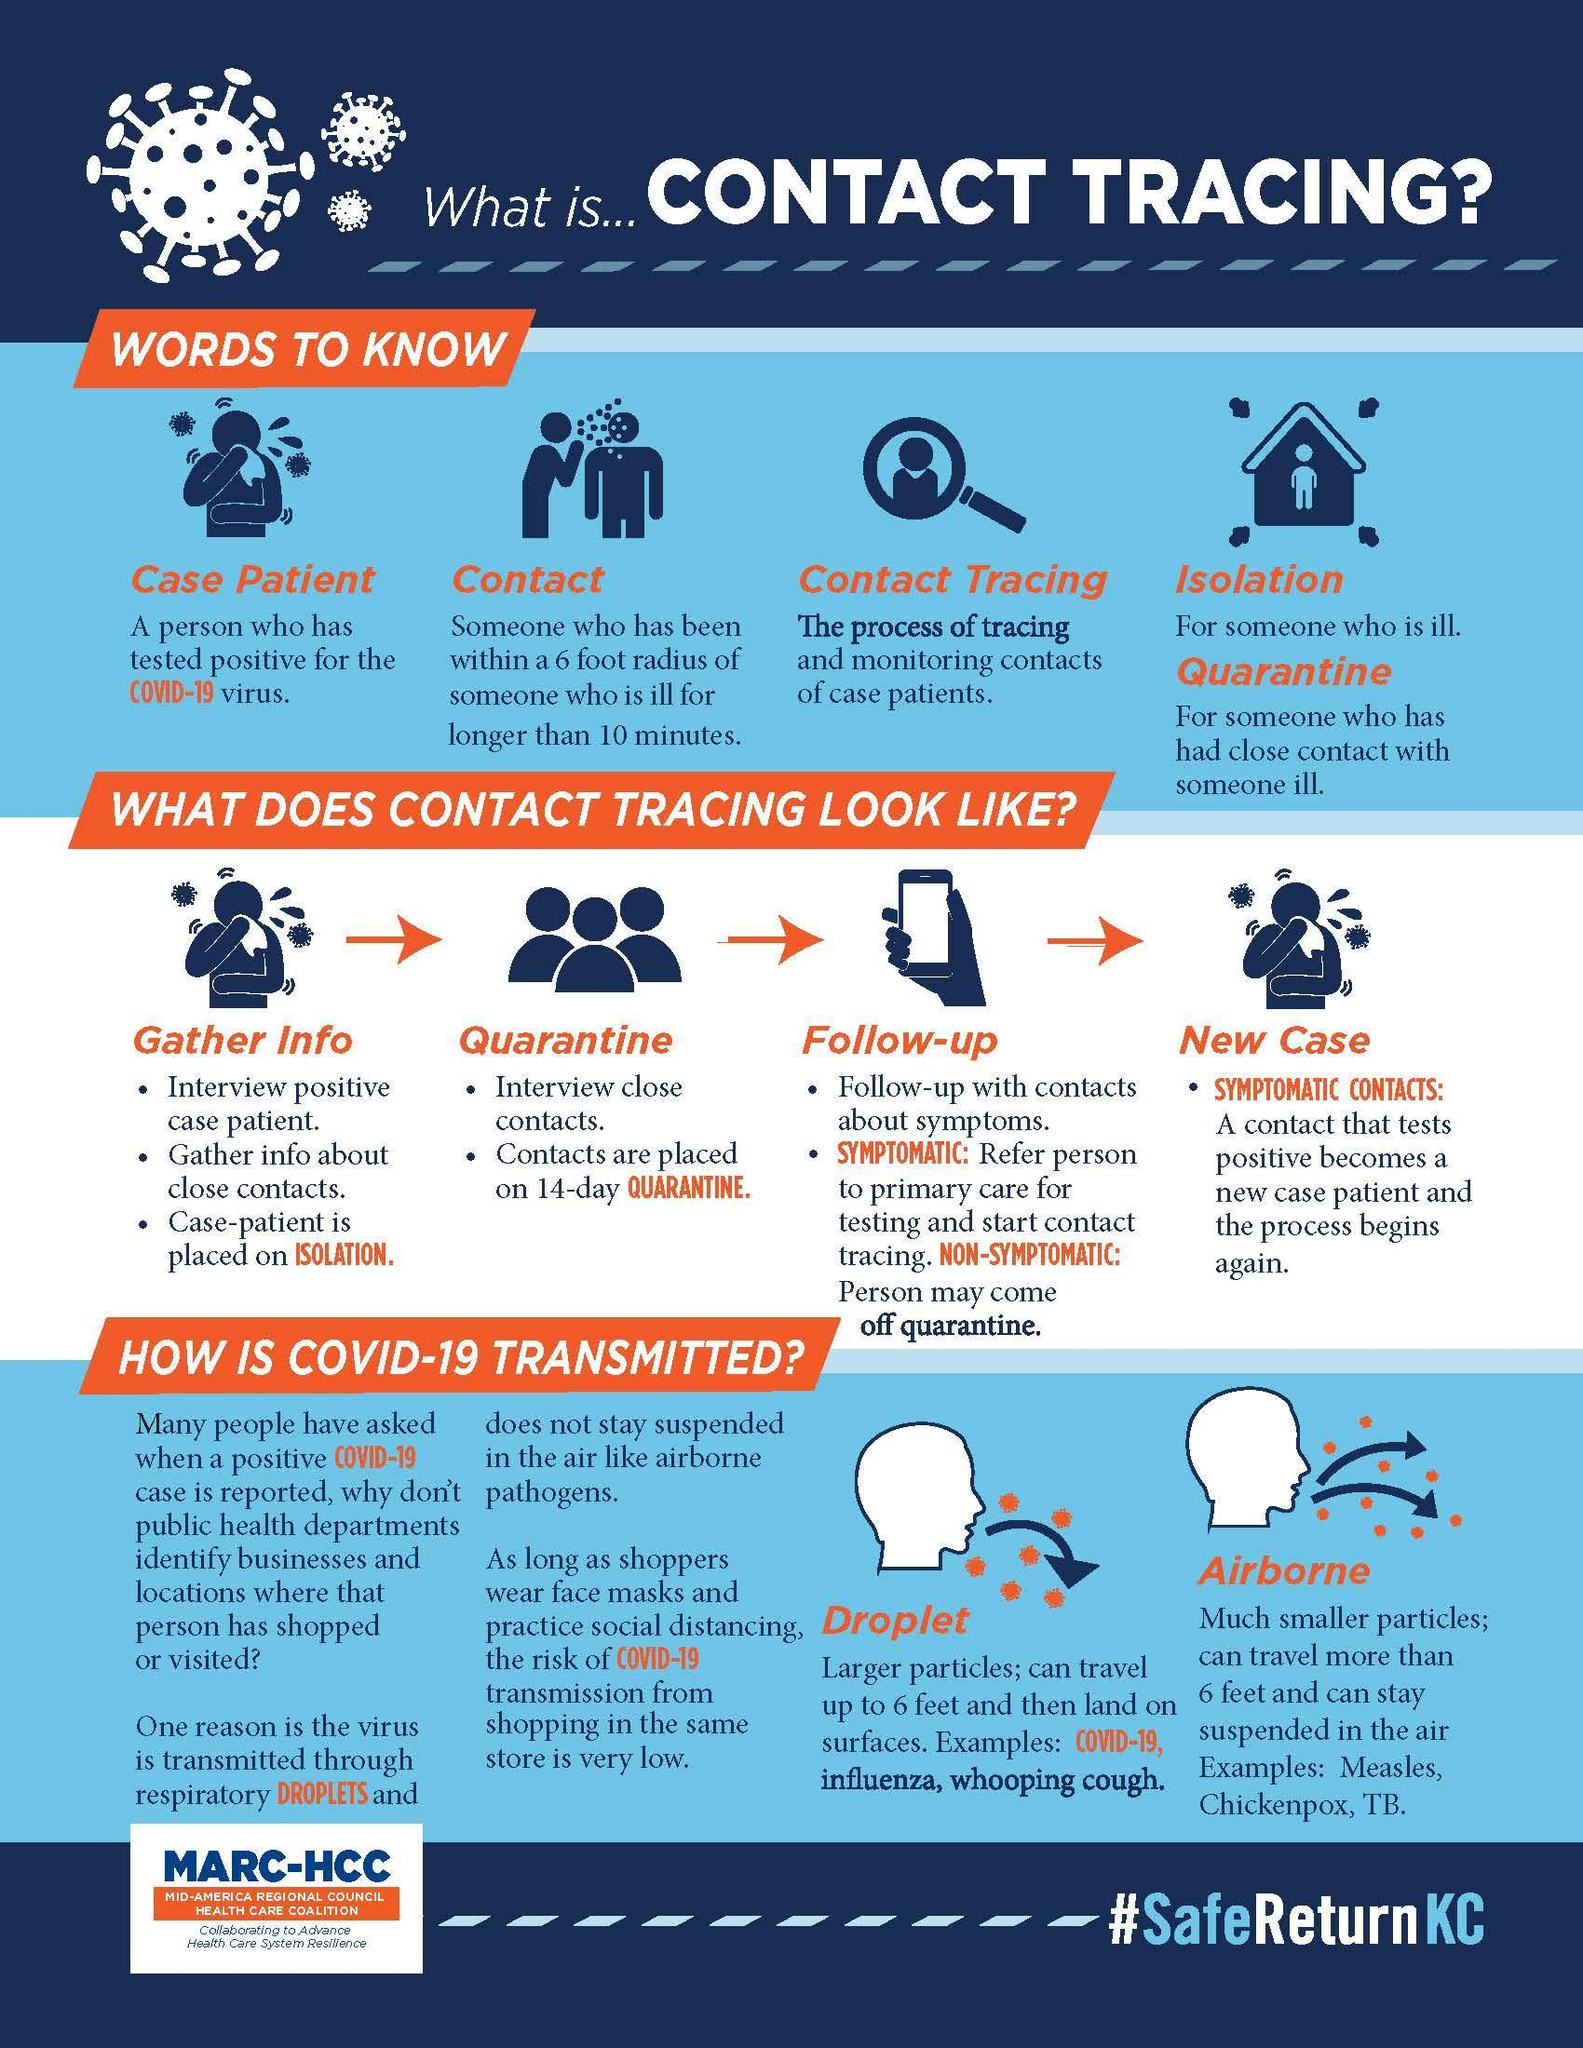How many types of symptoms?
Answer the question with a short phrase. 2 Which all are the droplets transmitting diseases? Covid-19, influenza, whooping cough How many ways does Covid-19 get transmitted? 2 Which all are the airborne diseases? Measles, Chickenpox, TB How many steps are under the heading Quarantine? 2 